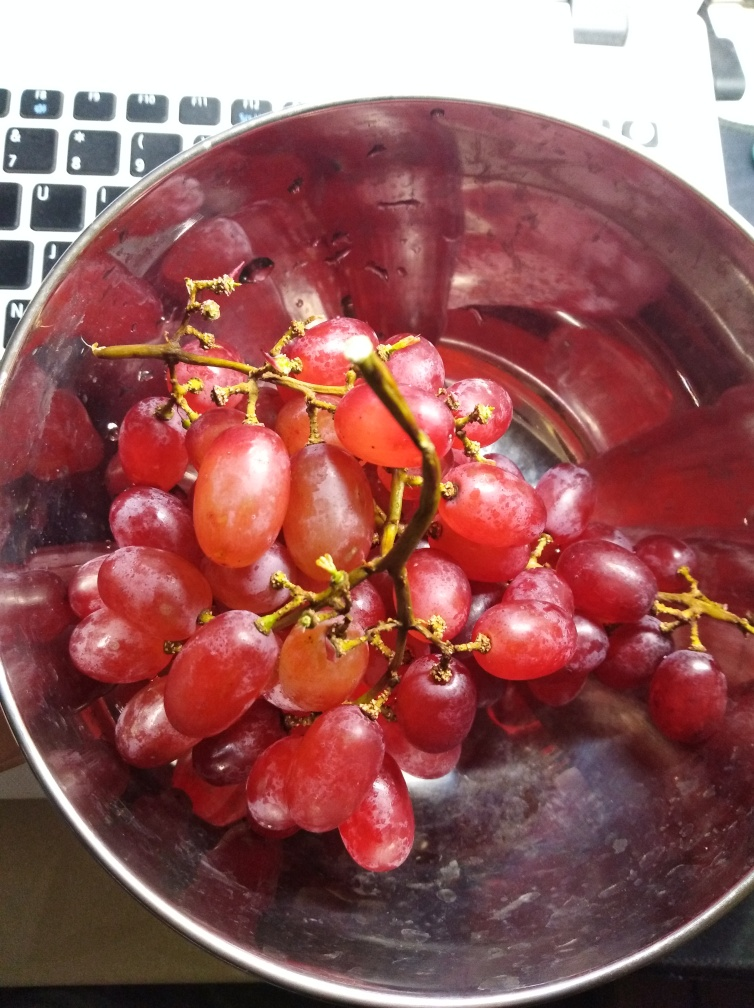Is there any indication of the variety of grapes in the image? The image presents a bunch of grapes that resemble red or purple table grapes, commonly enjoyed as a fresh fruit. They are likely a seedless variety, considering their uniform size and the absence of seeds visible at the grape's surface when closely examined. However, without a definitive label or additional context, it would be challenging to precisely identify the specific cultivar. 